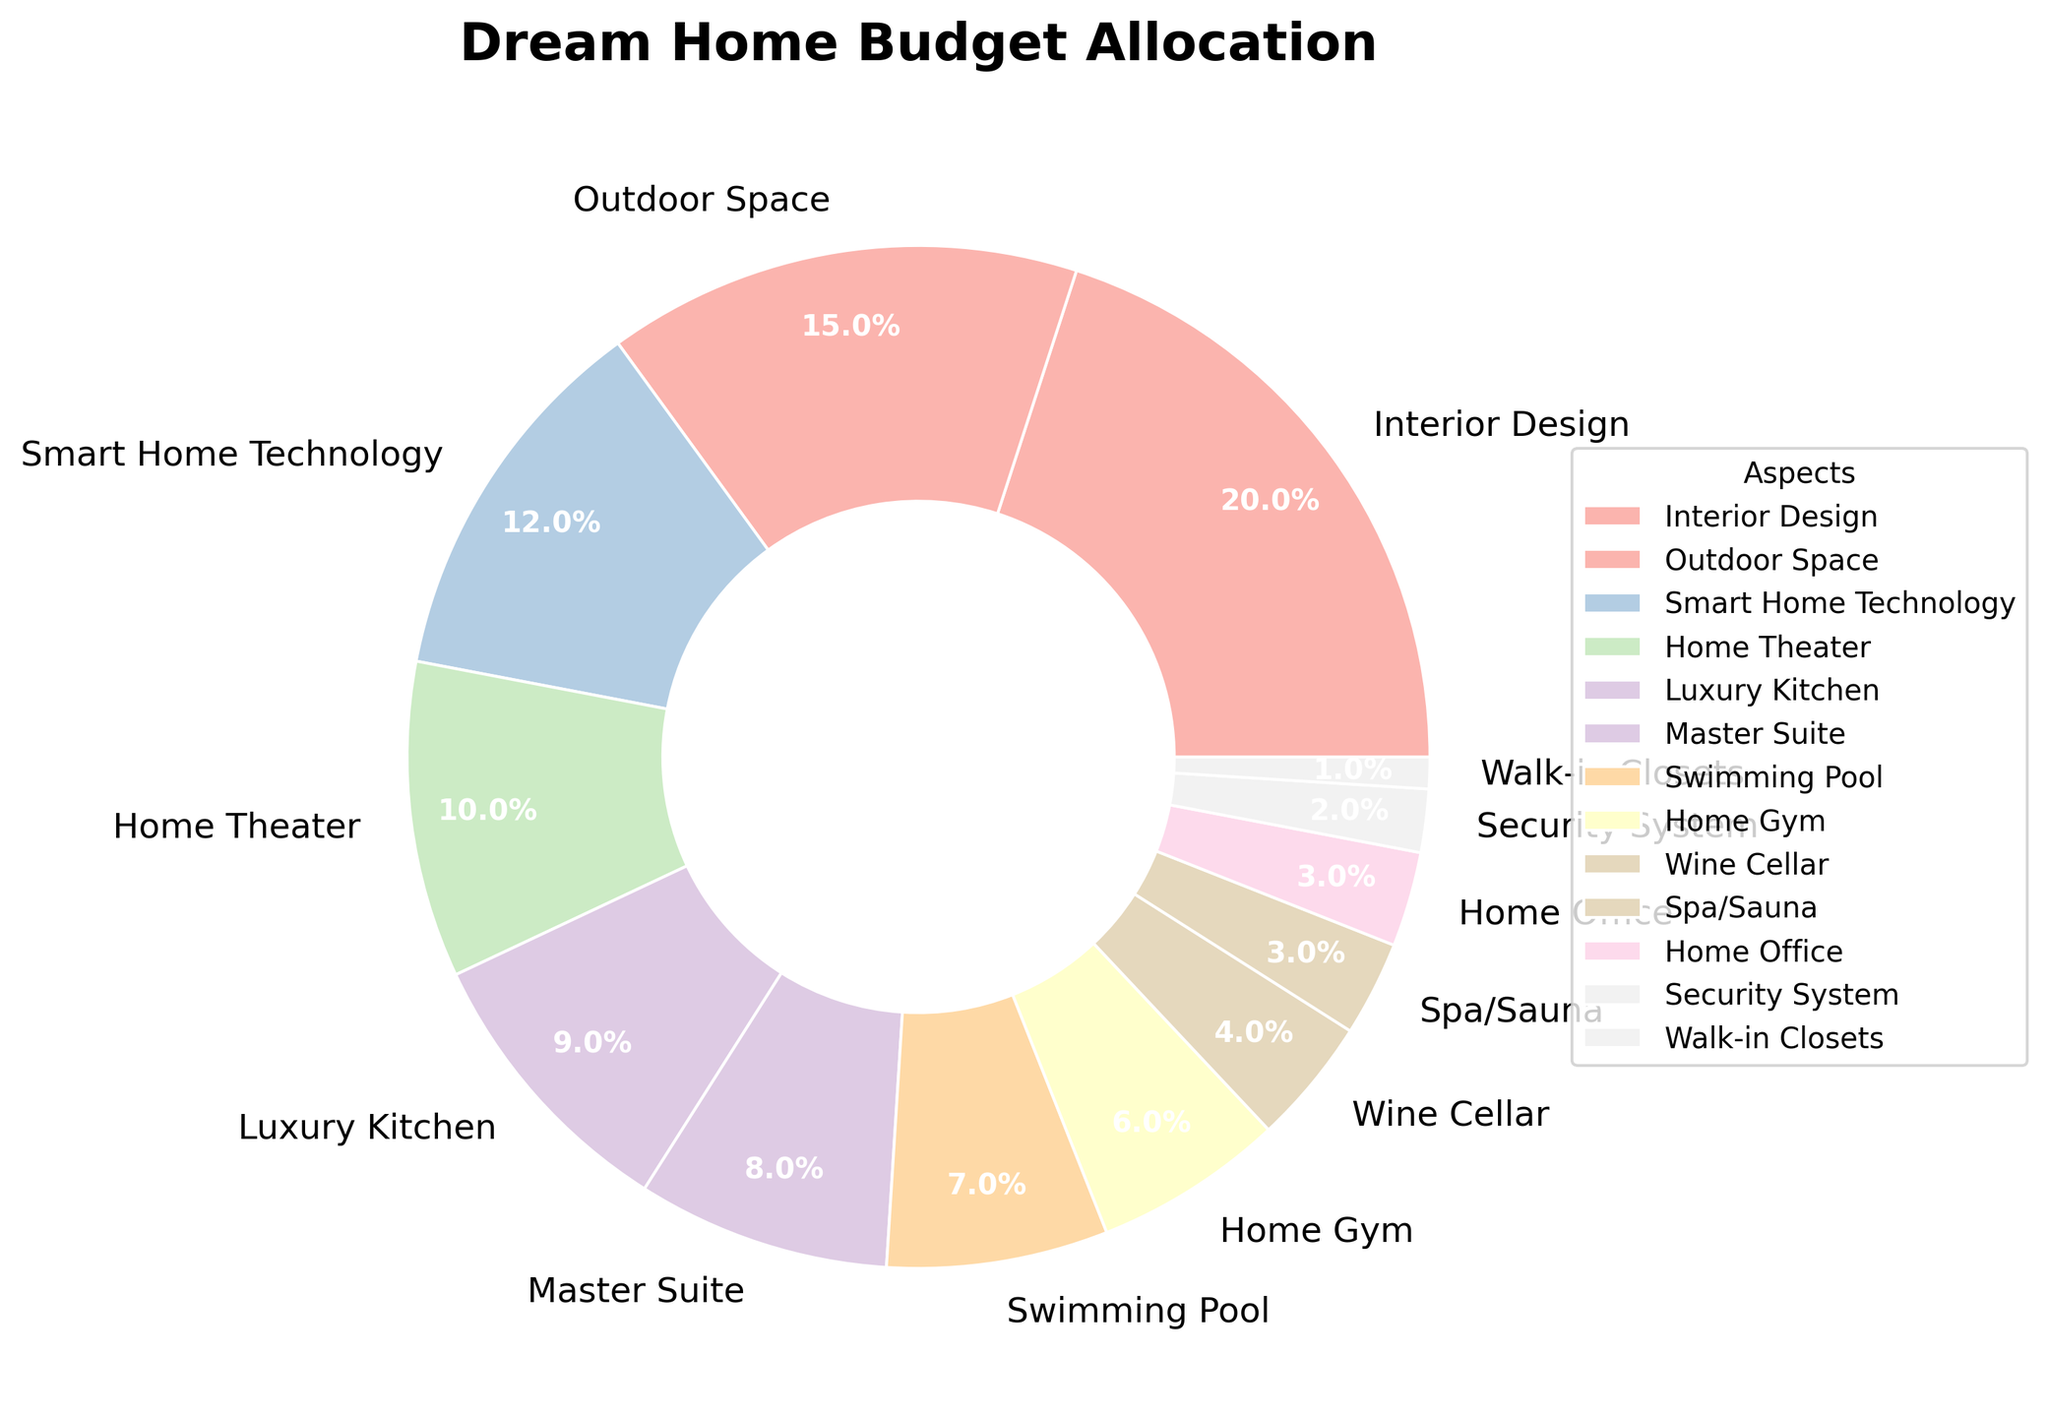What's the heaviest budgeted aspect in your dream home? The pie chart shows the percentage allocations for different aspects of a dream home. The largest wedge in the pie chart represents the aspect with the highest percentage, which is Interior Design at 20%.
Answer: Interior Design What's the combined budget percentage for Home Gym, Wine Cellar, and Spa/Sauna? To find the combined percentage, add the percentages of Home Gym (6%), Wine Cellar (4%), and Spa/Sauna (3%). This gives 6 + 4 + 3 = 13%.
Answer: 13% Which aspect has a higher budget allocation: Home Theater or Luxury Kitchen? Compare the pie wedges for Home Theater and Luxury Kitchen. Home Theater has 10% and Luxury Kitchen has 9%. Since 10% is greater than 9%, Home Theater has a higher budget allocation.
Answer: Home Theater How much more is allocated to Outdoor Space compared to Security System? Subtract the percentage of Security System (2%) from the percentage of Outdoor Space (15%). This gives 15 - 2 = 13%.
Answer: 13% Which aspects have the smallest budget allocations? Identify the smallest wedges in the pie chart. The aspects with the lowest percentages are Walk-in Closets at 1%, Security System at 2%, and Home Office at 3%.
Answer: Walk-in Closets, Security System, Home Office Is the combined budget for Master Suite and Swimming Pool more than that for Smart Home Technology? Calculate the combined percentage for Master Suite (8%) and Swimming Pool (7%), which is 8 + 7 = 15%. Compare it with Smart Home Technology's percentage (12%). Since 15% is greater than 12%, the combined budget for Master Suite and Swimming Pool is more.
Answer: Yes What's the percentage difference between the highest and the lowest budgeted aspects? The highest budgeted aspect is Interior Design at 20%, and the lowest is Walk-in Closets at 1%. Subtract the lowest percentage from the highest: 20 - 1 = 19%.
Answer: 19% What aspects together make up one-third of the total budget if combined? One-third of 100% is approximately 33.3%. Adding the percentages of Interior Design (20%) and Outdoor Space (15%) gives 20 + 15 = 35%, which is slightly more than one-third. Therefore, these two aspects combined closely approximate one-third of the budget.
Answer: Interior Design and Outdoor Space Are there more aspects with a budget allocation below or above 10%? Count the aspects above 10%: Interior Design (20%), Outdoor Space (15%), and Smart Home Technology (12%) — total 3 aspects. Count the aspects below 10%: Home Theater (10%), Luxury Kitchen (9%), Master Suite (8%), Swimming Pool (7%), Home Gym (6%), Wine Cellar (4%), Spa/Sauna (3%), Home Office (3%), Security System (2%), Walk-in Closets (1%) — total 10 aspects. There are more aspects with a budget below 10%.
Answer: Below What's the average budget allocation for all the aspects listed? Sum all the percentages and divide by the number of aspects: (20 + 15 + 12 + 10 + 9 + 8 + 7 + 6 + 4 + 3 + 3 + 2 + 1) = 100%. There are 13 aspects, so the average is 100 / 13 ≈ 7.69%.
Answer: Approximately 7.69% 